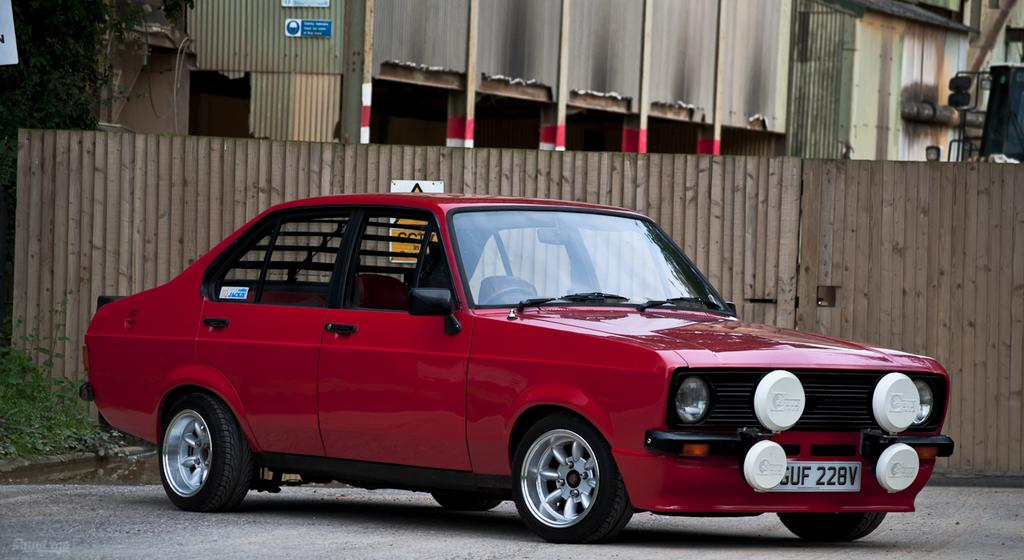What color is the car in the image? The car in the image is red. How many cushions are on the car's seat in the image? There is no information about cushions or seats in the image, as it only mentions a red color car. 